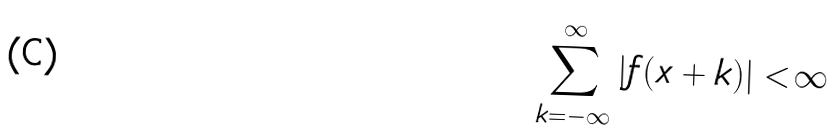Convert formula to latex. <formula><loc_0><loc_0><loc_500><loc_500>\sum _ { k = - \infty } ^ { \infty } | f ( x + k ) | < \infty</formula> 